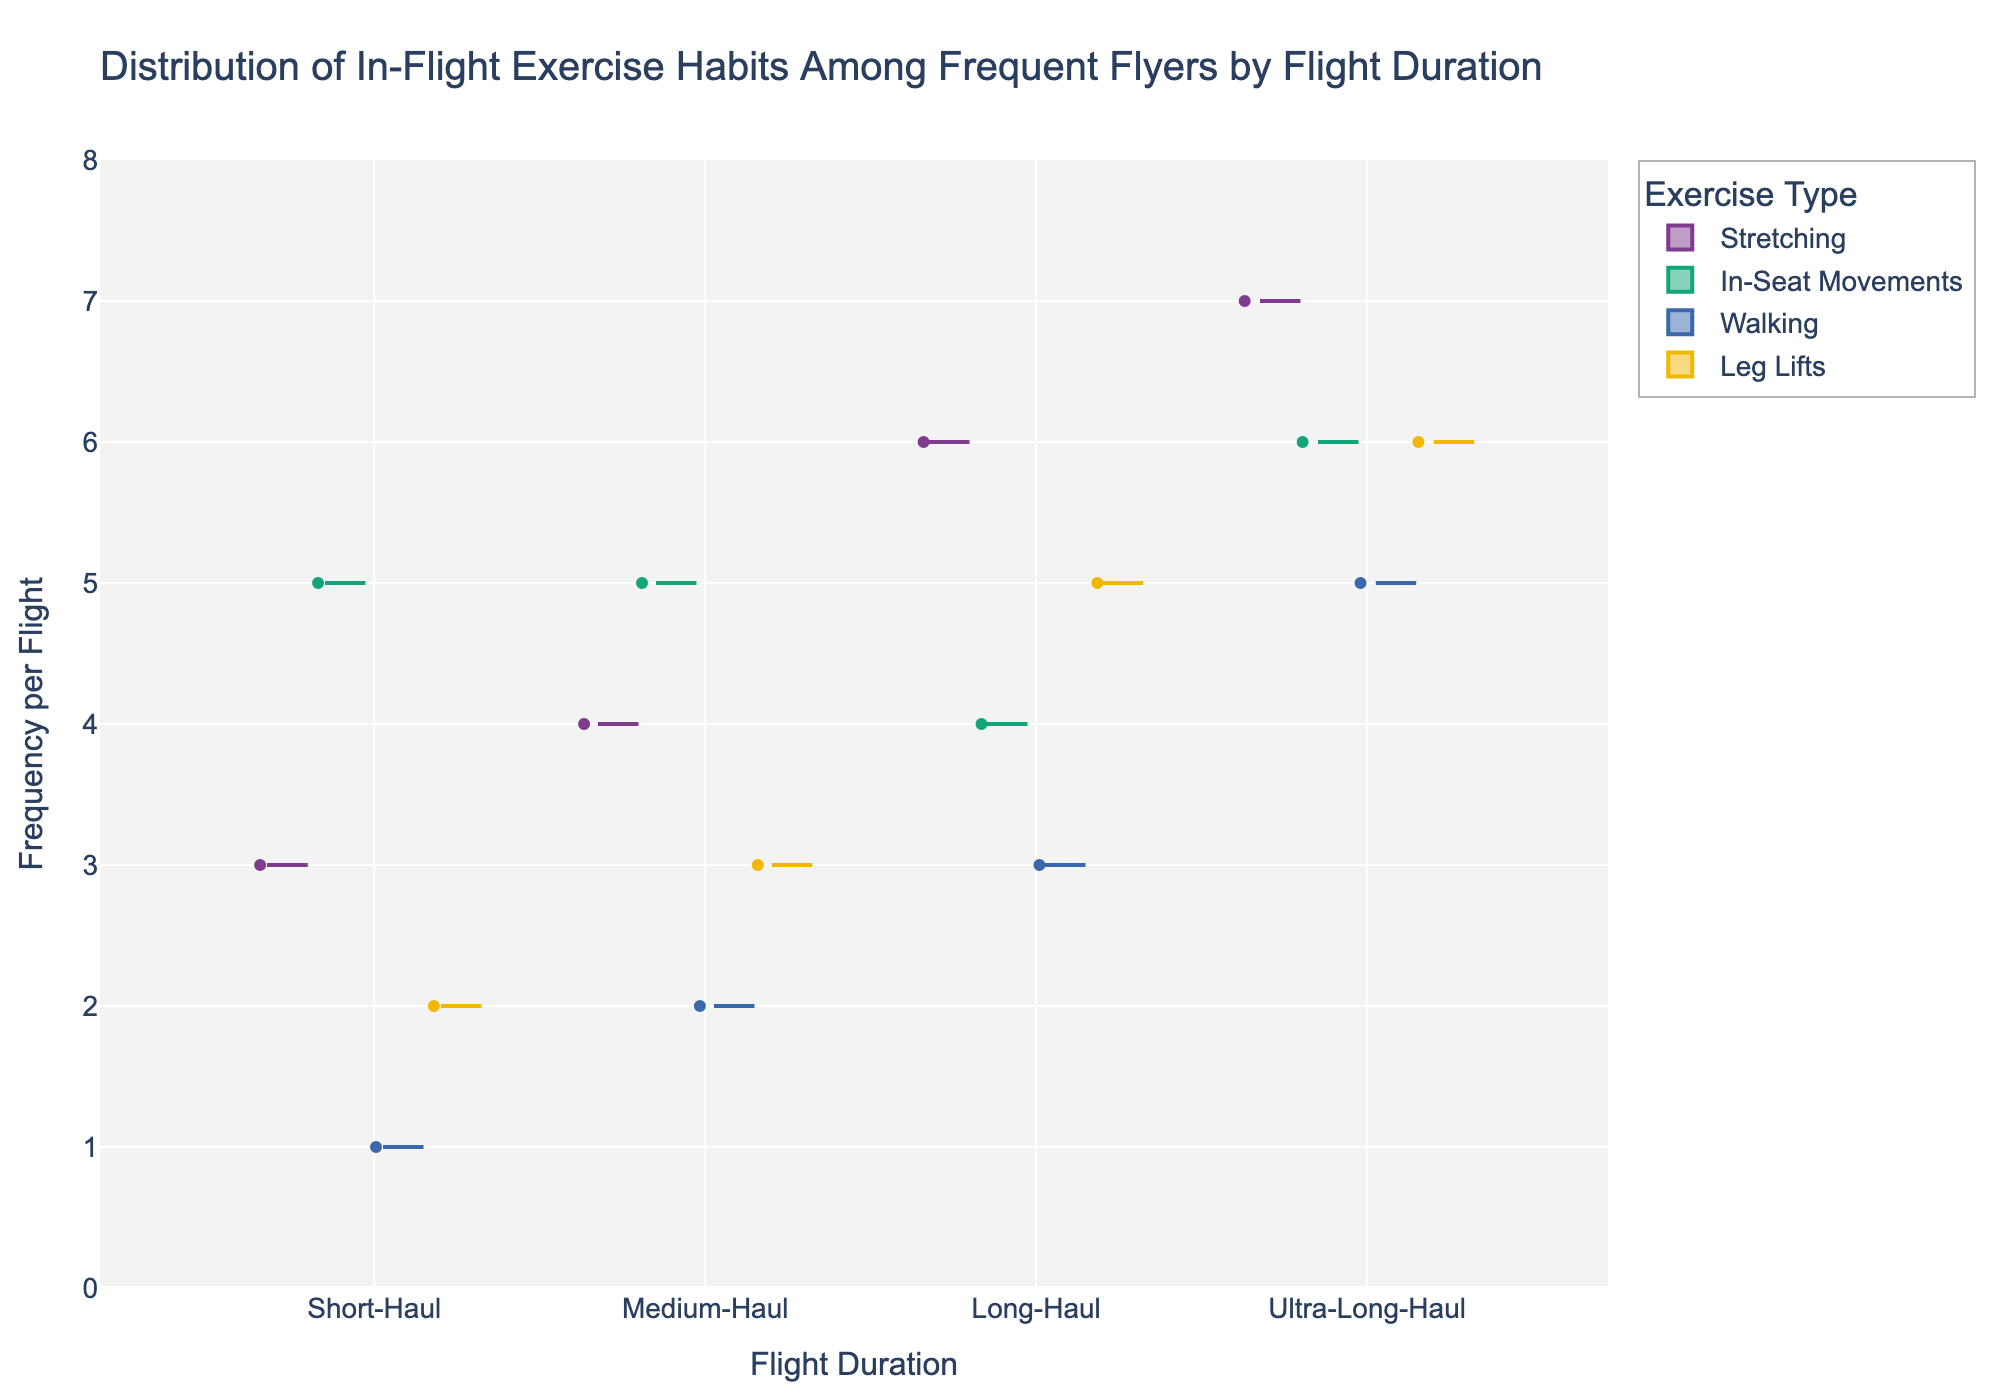What's the title of the figure? The title is usually located at the top of the figure. In this case, it states "Distribution of In-Flight Exercise Habits Among Frequent Flyers by Flight Duration."
Answer: Distribution of In-Flight Exercise Habits Among Frequent Flyers by Flight Duration Which exercise type has the highest median frequency per flight for Ultra-Long-Haul flights? For Ultra-Long-Haul flights, look for the exercise type with the highest median line (the middle line in the box) within the violin plot. For Ultra-Long-Haul, 'Stretching' shows the highest median frequency.
Answer: Stretching Between Short-Haul and Long-Haul flights, which has a higher median frequency for Leg Lifts? Compare the median lines (the middle line inside the box plot) for Leg Lifts within the Short-Haul and Long-Haul sections. Long-Haul has a higher median frequency than Short-Haul for Leg Lifts.
Answer: Long-Haul How many exercise types are analyzed in the plot? Count the different colors or labels representing the exercise types in the figure. There are four exercise types: Stretching, In-Seat Movements, Walking, and Leg Lifts.
Answer: Four Which flight duration shows the widest distribution in frequency for Walking? The width of the distribution in a violin plot indicates variability. Ultra-Long-Haul has the widest distribution for Walking, suggesting the greatest variability in the frequency of this exercise type.
Answer: Ultra-Long-Haul What is the trend in median frequency of Stretching as flight duration increases? Observe the median lines for Stretching across different flight durations (Short-Haul, Medium-Haul, Long-Haul, and Ultra-Long-Haul). The median frequency of Stretching increases with flight duration.
Answer: Increases Which flight duration has the narrowest distribution for In-Seat Movements? Look for the thinnest part of the violin plot for In-Seat Movements across all flight durations. Long-Haul has the narrowest distribution for this exercise type.
Answer: Long-Haul Is there any exercise type with the same median frequency across all flight durations? Compare the median lines for each exercise type across the different flight durations. None of the exercise types has the same median frequency across all flight durations.
Answer: No Which exercise type shows the least variance in frequency for Medium-Haul flights? Least variance can be identified by the narrowest width of the distribution in the violin plot. For Medium-Haul flights, In-Seat Movements show the least variance.
Answer: In-Seat Movements Are the variations in frequencies for Leg Lifts different between Medium-Haul and Ultra-Long-Haul flights? Observe the width of the distributions in the violin plots for Leg Lifts. Medium-Haul has a narrower distribution compared to Ultra-Long-Haul, indicating less variation in frequency.
Answer: Yes 